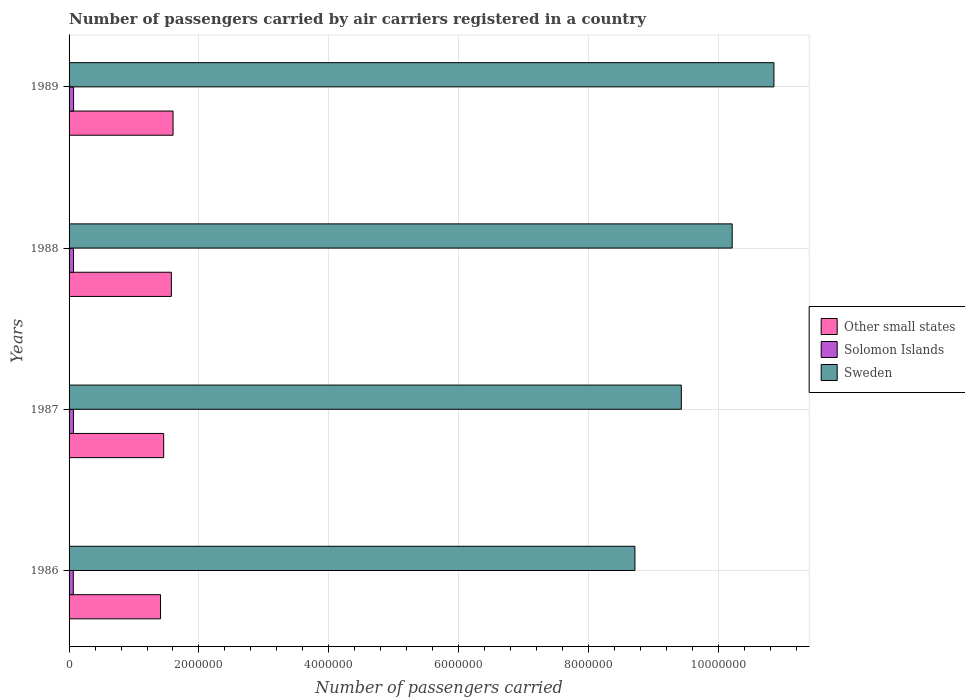How many groups of bars are there?
Provide a succinct answer. 4. Are the number of bars per tick equal to the number of legend labels?
Provide a short and direct response. Yes. What is the number of passengers carried by air carriers in Other small states in 1986?
Give a very brief answer. 1.41e+06. Across all years, what is the maximum number of passengers carried by air carriers in Other small states?
Your answer should be compact. 1.60e+06. Across all years, what is the minimum number of passengers carried by air carriers in Other small states?
Provide a succinct answer. 1.41e+06. What is the total number of passengers carried by air carriers in Sweden in the graph?
Provide a short and direct response. 3.92e+07. What is the difference between the number of passengers carried by air carriers in Solomon Islands in 1986 and that in 1988?
Provide a short and direct response. -3600. What is the difference between the number of passengers carried by air carriers in Solomon Islands in 1988 and the number of passengers carried by air carriers in Sweden in 1989?
Offer a very short reply. -1.08e+07. What is the average number of passengers carried by air carriers in Other small states per year?
Give a very brief answer. 1.51e+06. In the year 1989, what is the difference between the number of passengers carried by air carriers in Other small states and number of passengers carried by air carriers in Sweden?
Provide a short and direct response. -9.25e+06. What is the ratio of the number of passengers carried by air carriers in Solomon Islands in 1987 to that in 1988?
Offer a terse response. 0.99. Is the number of passengers carried by air carriers in Solomon Islands in 1987 less than that in 1988?
Ensure brevity in your answer.  Yes. Is the difference between the number of passengers carried by air carriers in Other small states in 1986 and 1987 greater than the difference between the number of passengers carried by air carriers in Sweden in 1986 and 1987?
Offer a terse response. Yes. What is the difference between the highest and the second highest number of passengers carried by air carriers in Sweden?
Provide a short and direct response. 6.43e+05. What is the difference between the highest and the lowest number of passengers carried by air carriers in Solomon Islands?
Give a very brief answer. 4400. In how many years, is the number of passengers carried by air carriers in Sweden greater than the average number of passengers carried by air carriers in Sweden taken over all years?
Your response must be concise. 2. Is the sum of the number of passengers carried by air carriers in Sweden in 1986 and 1988 greater than the maximum number of passengers carried by air carriers in Other small states across all years?
Ensure brevity in your answer.  Yes. What does the 2nd bar from the bottom in 1987 represents?
Offer a terse response. Solomon Islands. How many bars are there?
Provide a succinct answer. 12. What is the difference between two consecutive major ticks on the X-axis?
Provide a succinct answer. 2.00e+06. Are the values on the major ticks of X-axis written in scientific E-notation?
Give a very brief answer. No. Does the graph contain any zero values?
Make the answer very short. No. How many legend labels are there?
Your answer should be compact. 3. How are the legend labels stacked?
Offer a terse response. Vertical. What is the title of the graph?
Your answer should be compact. Number of passengers carried by air carriers registered in a country. Does "Middle East & North Africa (developing only)" appear as one of the legend labels in the graph?
Ensure brevity in your answer.  No. What is the label or title of the X-axis?
Provide a succinct answer. Number of passengers carried. What is the Number of passengers carried in Other small states in 1986?
Make the answer very short. 1.41e+06. What is the Number of passengers carried of Solomon Islands in 1986?
Your answer should be very brief. 6.49e+04. What is the Number of passengers carried in Sweden in 1986?
Ensure brevity in your answer.  8.71e+06. What is the Number of passengers carried of Other small states in 1987?
Offer a very short reply. 1.46e+06. What is the Number of passengers carried in Solomon Islands in 1987?
Your answer should be very brief. 6.75e+04. What is the Number of passengers carried in Sweden in 1987?
Your response must be concise. 9.43e+06. What is the Number of passengers carried of Other small states in 1988?
Provide a short and direct response. 1.58e+06. What is the Number of passengers carried in Solomon Islands in 1988?
Your answer should be compact. 6.85e+04. What is the Number of passengers carried in Sweden in 1988?
Give a very brief answer. 1.02e+07. What is the Number of passengers carried of Other small states in 1989?
Your response must be concise. 1.60e+06. What is the Number of passengers carried in Solomon Islands in 1989?
Provide a succinct answer. 6.93e+04. What is the Number of passengers carried of Sweden in 1989?
Keep it short and to the point. 1.09e+07. Across all years, what is the maximum Number of passengers carried in Other small states?
Your answer should be compact. 1.60e+06. Across all years, what is the maximum Number of passengers carried in Solomon Islands?
Offer a terse response. 6.93e+04. Across all years, what is the maximum Number of passengers carried in Sweden?
Give a very brief answer. 1.09e+07. Across all years, what is the minimum Number of passengers carried of Other small states?
Provide a succinct answer. 1.41e+06. Across all years, what is the minimum Number of passengers carried in Solomon Islands?
Provide a short and direct response. 6.49e+04. Across all years, what is the minimum Number of passengers carried of Sweden?
Give a very brief answer. 8.71e+06. What is the total Number of passengers carried of Other small states in the graph?
Your answer should be compact. 6.04e+06. What is the total Number of passengers carried in Solomon Islands in the graph?
Your answer should be very brief. 2.70e+05. What is the total Number of passengers carried in Sweden in the graph?
Give a very brief answer. 3.92e+07. What is the difference between the Number of passengers carried in Other small states in 1986 and that in 1987?
Provide a short and direct response. -4.85e+04. What is the difference between the Number of passengers carried of Solomon Islands in 1986 and that in 1987?
Offer a very short reply. -2600. What is the difference between the Number of passengers carried of Sweden in 1986 and that in 1987?
Your answer should be compact. -7.15e+05. What is the difference between the Number of passengers carried in Other small states in 1986 and that in 1988?
Offer a terse response. -1.67e+05. What is the difference between the Number of passengers carried of Solomon Islands in 1986 and that in 1988?
Offer a terse response. -3600. What is the difference between the Number of passengers carried of Sweden in 1986 and that in 1988?
Keep it short and to the point. -1.50e+06. What is the difference between the Number of passengers carried in Other small states in 1986 and that in 1989?
Provide a succinct answer. -1.93e+05. What is the difference between the Number of passengers carried of Solomon Islands in 1986 and that in 1989?
Provide a succinct answer. -4400. What is the difference between the Number of passengers carried of Sweden in 1986 and that in 1989?
Ensure brevity in your answer.  -2.14e+06. What is the difference between the Number of passengers carried of Other small states in 1987 and that in 1988?
Ensure brevity in your answer.  -1.18e+05. What is the difference between the Number of passengers carried in Solomon Islands in 1987 and that in 1988?
Make the answer very short. -1000. What is the difference between the Number of passengers carried of Sweden in 1987 and that in 1988?
Offer a very short reply. -7.83e+05. What is the difference between the Number of passengers carried of Other small states in 1987 and that in 1989?
Offer a very short reply. -1.44e+05. What is the difference between the Number of passengers carried of Solomon Islands in 1987 and that in 1989?
Your answer should be compact. -1800. What is the difference between the Number of passengers carried in Sweden in 1987 and that in 1989?
Give a very brief answer. -1.43e+06. What is the difference between the Number of passengers carried in Other small states in 1988 and that in 1989?
Offer a very short reply. -2.64e+04. What is the difference between the Number of passengers carried of Solomon Islands in 1988 and that in 1989?
Offer a terse response. -800. What is the difference between the Number of passengers carried of Sweden in 1988 and that in 1989?
Your answer should be compact. -6.43e+05. What is the difference between the Number of passengers carried in Other small states in 1986 and the Number of passengers carried in Solomon Islands in 1987?
Make the answer very short. 1.34e+06. What is the difference between the Number of passengers carried of Other small states in 1986 and the Number of passengers carried of Sweden in 1987?
Offer a very short reply. -8.02e+06. What is the difference between the Number of passengers carried in Solomon Islands in 1986 and the Number of passengers carried in Sweden in 1987?
Your answer should be compact. -9.36e+06. What is the difference between the Number of passengers carried in Other small states in 1986 and the Number of passengers carried in Solomon Islands in 1988?
Provide a succinct answer. 1.34e+06. What is the difference between the Number of passengers carried in Other small states in 1986 and the Number of passengers carried in Sweden in 1988?
Keep it short and to the point. -8.80e+06. What is the difference between the Number of passengers carried in Solomon Islands in 1986 and the Number of passengers carried in Sweden in 1988?
Your answer should be very brief. -1.01e+07. What is the difference between the Number of passengers carried in Other small states in 1986 and the Number of passengers carried in Solomon Islands in 1989?
Keep it short and to the point. 1.34e+06. What is the difference between the Number of passengers carried in Other small states in 1986 and the Number of passengers carried in Sweden in 1989?
Your response must be concise. -9.45e+06. What is the difference between the Number of passengers carried of Solomon Islands in 1986 and the Number of passengers carried of Sweden in 1989?
Provide a succinct answer. -1.08e+07. What is the difference between the Number of passengers carried in Other small states in 1987 and the Number of passengers carried in Solomon Islands in 1988?
Ensure brevity in your answer.  1.39e+06. What is the difference between the Number of passengers carried in Other small states in 1987 and the Number of passengers carried in Sweden in 1988?
Provide a short and direct response. -8.75e+06. What is the difference between the Number of passengers carried of Solomon Islands in 1987 and the Number of passengers carried of Sweden in 1988?
Offer a terse response. -1.01e+07. What is the difference between the Number of passengers carried of Other small states in 1987 and the Number of passengers carried of Solomon Islands in 1989?
Provide a succinct answer. 1.39e+06. What is the difference between the Number of passengers carried of Other small states in 1987 and the Number of passengers carried of Sweden in 1989?
Make the answer very short. -9.40e+06. What is the difference between the Number of passengers carried of Solomon Islands in 1987 and the Number of passengers carried of Sweden in 1989?
Offer a very short reply. -1.08e+07. What is the difference between the Number of passengers carried of Other small states in 1988 and the Number of passengers carried of Solomon Islands in 1989?
Give a very brief answer. 1.51e+06. What is the difference between the Number of passengers carried in Other small states in 1988 and the Number of passengers carried in Sweden in 1989?
Your answer should be compact. -9.28e+06. What is the difference between the Number of passengers carried of Solomon Islands in 1988 and the Number of passengers carried of Sweden in 1989?
Your answer should be very brief. -1.08e+07. What is the average Number of passengers carried in Other small states per year?
Your answer should be very brief. 1.51e+06. What is the average Number of passengers carried of Solomon Islands per year?
Your response must be concise. 6.76e+04. What is the average Number of passengers carried in Sweden per year?
Offer a terse response. 9.80e+06. In the year 1986, what is the difference between the Number of passengers carried in Other small states and Number of passengers carried in Solomon Islands?
Provide a short and direct response. 1.34e+06. In the year 1986, what is the difference between the Number of passengers carried of Other small states and Number of passengers carried of Sweden?
Your answer should be very brief. -7.31e+06. In the year 1986, what is the difference between the Number of passengers carried in Solomon Islands and Number of passengers carried in Sweden?
Ensure brevity in your answer.  -8.65e+06. In the year 1987, what is the difference between the Number of passengers carried in Other small states and Number of passengers carried in Solomon Islands?
Your response must be concise. 1.39e+06. In the year 1987, what is the difference between the Number of passengers carried of Other small states and Number of passengers carried of Sweden?
Give a very brief answer. -7.97e+06. In the year 1987, what is the difference between the Number of passengers carried of Solomon Islands and Number of passengers carried of Sweden?
Provide a short and direct response. -9.36e+06. In the year 1988, what is the difference between the Number of passengers carried of Other small states and Number of passengers carried of Solomon Islands?
Provide a short and direct response. 1.51e+06. In the year 1988, what is the difference between the Number of passengers carried of Other small states and Number of passengers carried of Sweden?
Your answer should be very brief. -8.64e+06. In the year 1988, what is the difference between the Number of passengers carried of Solomon Islands and Number of passengers carried of Sweden?
Your answer should be compact. -1.01e+07. In the year 1989, what is the difference between the Number of passengers carried in Other small states and Number of passengers carried in Solomon Islands?
Ensure brevity in your answer.  1.53e+06. In the year 1989, what is the difference between the Number of passengers carried of Other small states and Number of passengers carried of Sweden?
Your answer should be very brief. -9.25e+06. In the year 1989, what is the difference between the Number of passengers carried of Solomon Islands and Number of passengers carried of Sweden?
Make the answer very short. -1.08e+07. What is the ratio of the Number of passengers carried in Other small states in 1986 to that in 1987?
Your response must be concise. 0.97. What is the ratio of the Number of passengers carried of Solomon Islands in 1986 to that in 1987?
Provide a short and direct response. 0.96. What is the ratio of the Number of passengers carried in Sweden in 1986 to that in 1987?
Offer a very short reply. 0.92. What is the ratio of the Number of passengers carried in Other small states in 1986 to that in 1988?
Offer a terse response. 0.89. What is the ratio of the Number of passengers carried in Solomon Islands in 1986 to that in 1988?
Give a very brief answer. 0.95. What is the ratio of the Number of passengers carried in Sweden in 1986 to that in 1988?
Your answer should be very brief. 0.85. What is the ratio of the Number of passengers carried of Other small states in 1986 to that in 1989?
Provide a succinct answer. 0.88. What is the ratio of the Number of passengers carried in Solomon Islands in 1986 to that in 1989?
Give a very brief answer. 0.94. What is the ratio of the Number of passengers carried in Sweden in 1986 to that in 1989?
Your answer should be very brief. 0.8. What is the ratio of the Number of passengers carried of Other small states in 1987 to that in 1988?
Your answer should be very brief. 0.93. What is the ratio of the Number of passengers carried in Solomon Islands in 1987 to that in 1988?
Your response must be concise. 0.99. What is the ratio of the Number of passengers carried of Sweden in 1987 to that in 1988?
Provide a succinct answer. 0.92. What is the ratio of the Number of passengers carried in Other small states in 1987 to that in 1989?
Offer a very short reply. 0.91. What is the ratio of the Number of passengers carried of Sweden in 1987 to that in 1989?
Provide a short and direct response. 0.87. What is the ratio of the Number of passengers carried of Other small states in 1988 to that in 1989?
Your answer should be very brief. 0.98. What is the ratio of the Number of passengers carried in Sweden in 1988 to that in 1989?
Offer a terse response. 0.94. What is the difference between the highest and the second highest Number of passengers carried in Other small states?
Offer a very short reply. 2.64e+04. What is the difference between the highest and the second highest Number of passengers carried of Solomon Islands?
Your answer should be very brief. 800. What is the difference between the highest and the second highest Number of passengers carried in Sweden?
Your response must be concise. 6.43e+05. What is the difference between the highest and the lowest Number of passengers carried of Other small states?
Provide a succinct answer. 1.93e+05. What is the difference between the highest and the lowest Number of passengers carried of Solomon Islands?
Give a very brief answer. 4400. What is the difference between the highest and the lowest Number of passengers carried of Sweden?
Ensure brevity in your answer.  2.14e+06. 